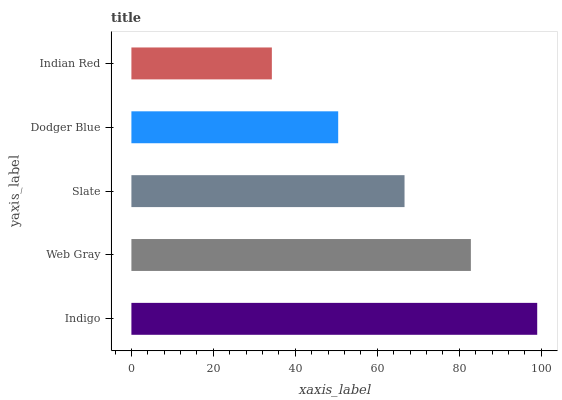Is Indian Red the minimum?
Answer yes or no. Yes. Is Indigo the maximum?
Answer yes or no. Yes. Is Web Gray the minimum?
Answer yes or no. No. Is Web Gray the maximum?
Answer yes or no. No. Is Indigo greater than Web Gray?
Answer yes or no. Yes. Is Web Gray less than Indigo?
Answer yes or no. Yes. Is Web Gray greater than Indigo?
Answer yes or no. No. Is Indigo less than Web Gray?
Answer yes or no. No. Is Slate the high median?
Answer yes or no. Yes. Is Slate the low median?
Answer yes or no. Yes. Is Indigo the high median?
Answer yes or no. No. Is Web Gray the low median?
Answer yes or no. No. 